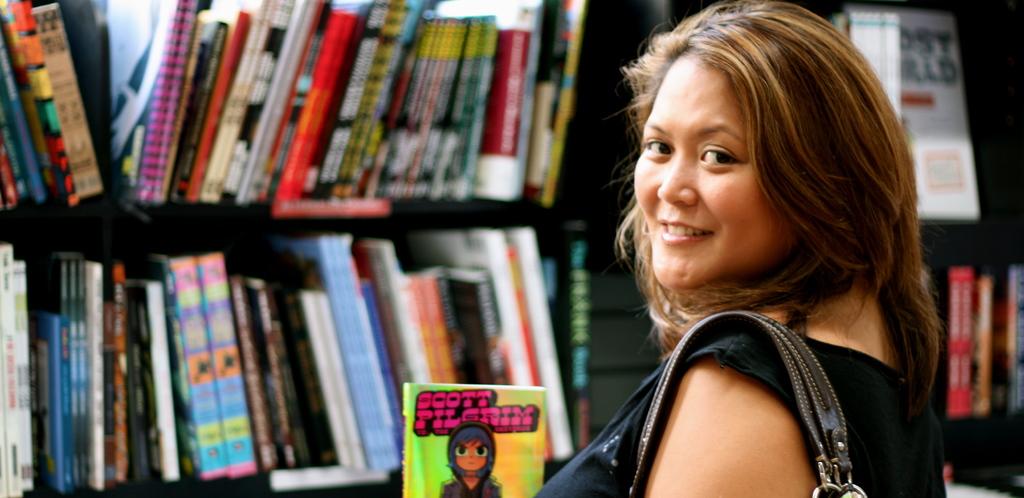What name is on the book the woman is holding?
Provide a short and direct response. Scott pilgrim. 